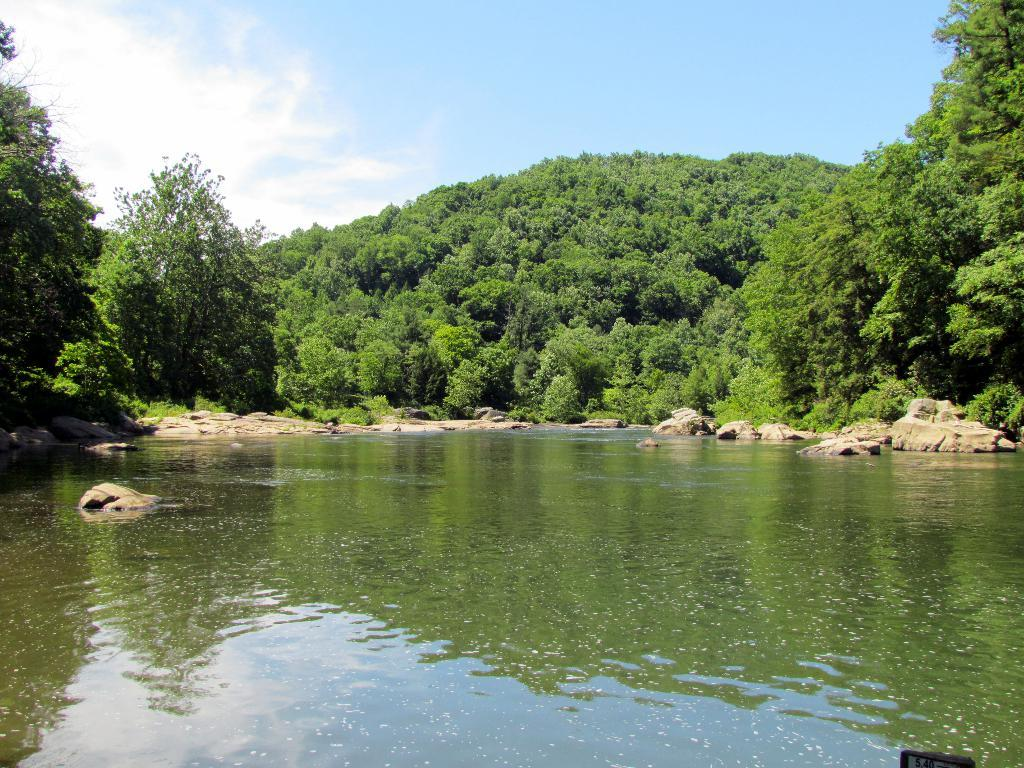What type of water body is present in the image? There is a river in the image. What can be found in the river? There are stones in the river. What is located near the river? There are trees near the river. What is visible in the background of the image? There is a mountain in the background of the image, and the sky is blue. What is the mountain covered with? The mountain is covered with trees. What type of glue is being used to hold the stones together in the river? There is no glue present in the image; the stones are naturally situated in the river. 